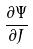Convert formula to latex. <formula><loc_0><loc_0><loc_500><loc_500>\frac { \partial \Psi } { \partial J }</formula> 